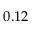<formula> <loc_0><loc_0><loc_500><loc_500>0 . 1 2</formula> 